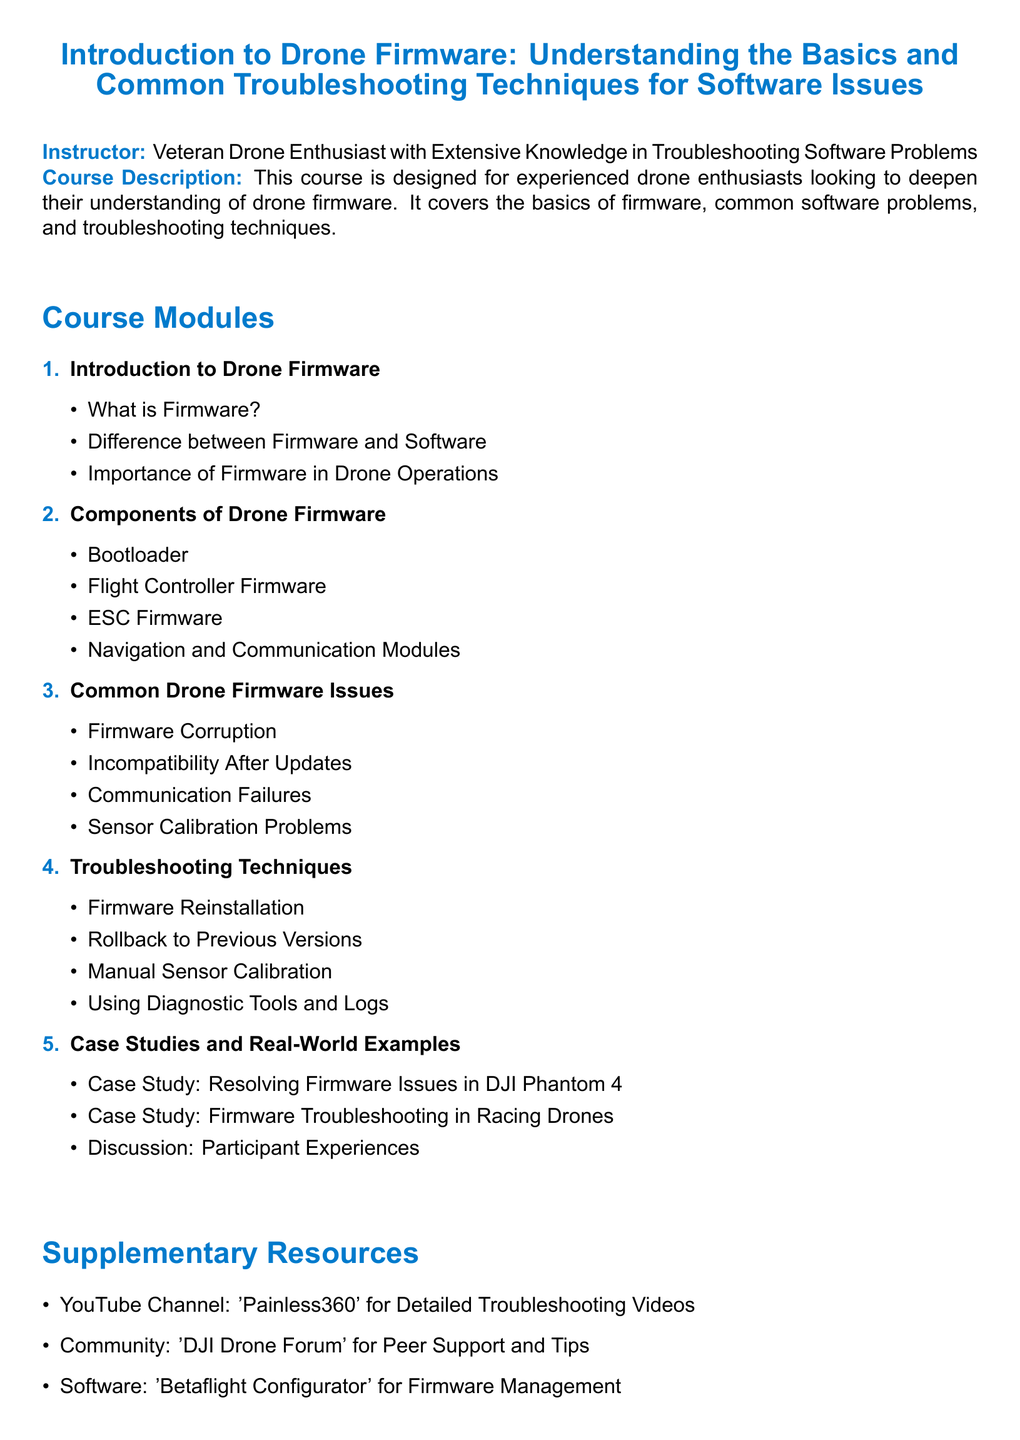What is the course title? The course title is stated prominently at the beginning of the document.
Answer: Introduction to Drone Firmware: Understanding the Basics and Common Troubleshooting Techniques for Software Issues Who is the instructor? The instructor's information is provided under the course info section.
Answer: Veteran Drone Enthusiast with Extensive Knowledge in Troubleshooting Software Problems How many modules are there in the course? The total number of modules is indicated by the enumerate list in the document.
Answer: 5 What is one of the common firmware issues? The common firmware issues are listed in one of the course modules.
Answer: Firmware Corruption What troubleshooting technique is mentioned? The troubleshooting techniques are outlined in a specific module of the syllabus.
Answer: Firmware Reinstallation What case study is included in the syllabus? One of the case studies is explicitly listed under the case studies section of the syllabus.
Answer: Resolving Firmware Issues in DJI Phantom 4 Which community resource is suggested? The supplementary resources section mentions various resources, including communities for support.
Answer: DJI Drone Forum What software is recommended for firmware management? The software resource is listed in the supplementary resources section for managing firmware.
Answer: Betaflight Configurator 